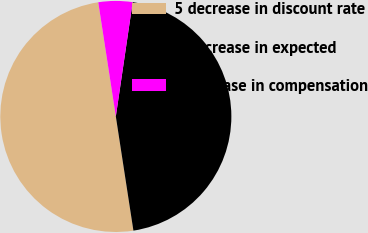Convert chart. <chart><loc_0><loc_0><loc_500><loc_500><pie_chart><fcel>5 decrease in discount rate<fcel>5 decrease in expected<fcel>5 increase in compensation<nl><fcel>50.0%<fcel>45.24%<fcel>4.76%<nl></chart> 